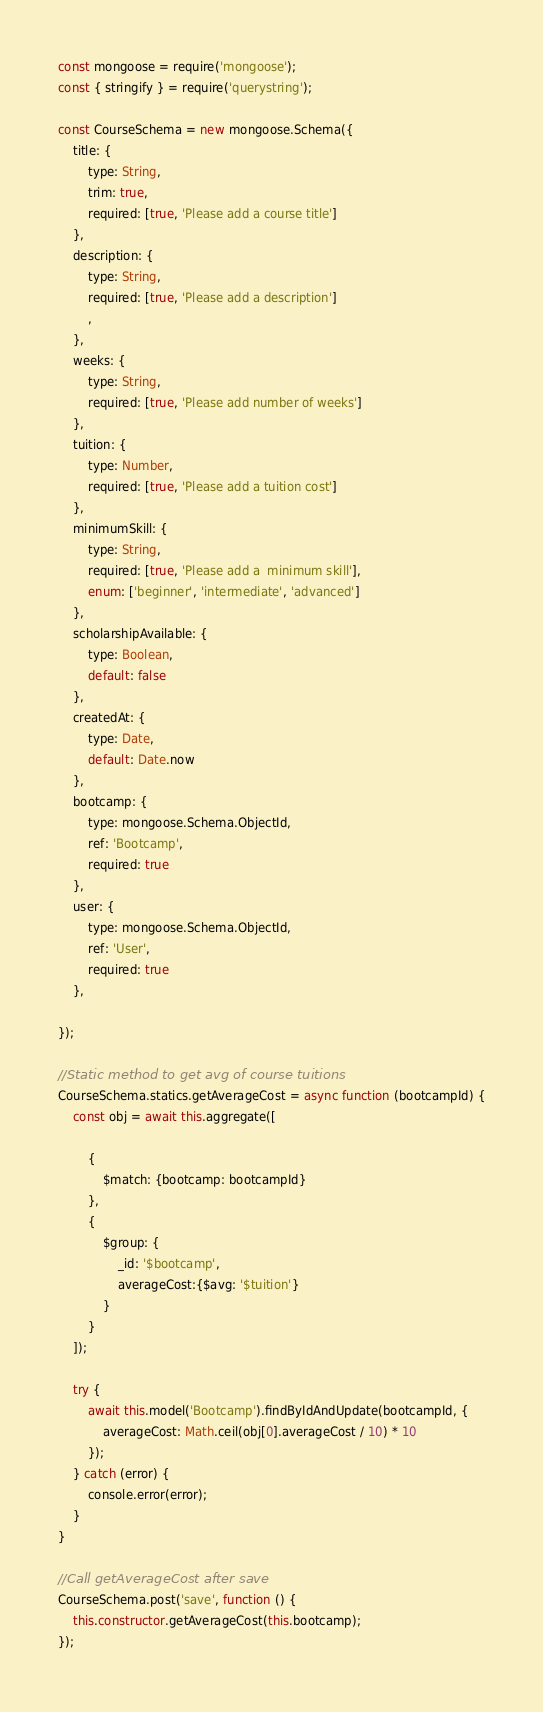Convert code to text. <code><loc_0><loc_0><loc_500><loc_500><_JavaScript_>const mongoose = require('mongoose');
const { stringify } = require('querystring');

const CourseSchema = new mongoose.Schema({
    title: {
        type: String,
        trim: true,
        required: [true, 'Please add a course title']
    },
    description: {
        type: String,
        required: [true, 'Please add a description']
        ,
    },
    weeks: {
        type: String,
        required: [true, 'Please add number of weeks']
    },
    tuition: {
        type: Number,
        required: [true, 'Please add a tuition cost']
    },
    minimumSkill: {
        type: String,
        required: [true, 'Please add a  minimum skill'],
        enum: ['beginner', 'intermediate', 'advanced']
    },
    scholarshipAvailable: {
        type: Boolean,
        default: false
    },
    createdAt: {
        type: Date,
        default: Date.now
    },
    bootcamp: {
        type: mongoose.Schema.ObjectId,
        ref: 'Bootcamp',
        required: true
    },
    user: {
        type: mongoose.Schema.ObjectId,
        ref: 'User',
        required: true
    },

});

//Static method to get avg of course tuitions
CourseSchema.statics.getAverageCost = async function (bootcampId) {
    const obj = await this.aggregate([

        {
            $match: {bootcamp: bootcampId}
        },
        {
            $group: {
                _id: '$bootcamp',
                averageCost:{$avg: '$tuition'}
            }
        }
    ]);

    try {
        await this.model('Bootcamp').findByIdAndUpdate(bootcampId, {
            averageCost: Math.ceil(obj[0].averageCost / 10) * 10
        });
    } catch (error) {
        console.error(error);
    }
}

//Call getAverageCost after save
CourseSchema.post('save', function () {
    this.constructor.getAverageCost(this.bootcamp);
});
</code> 